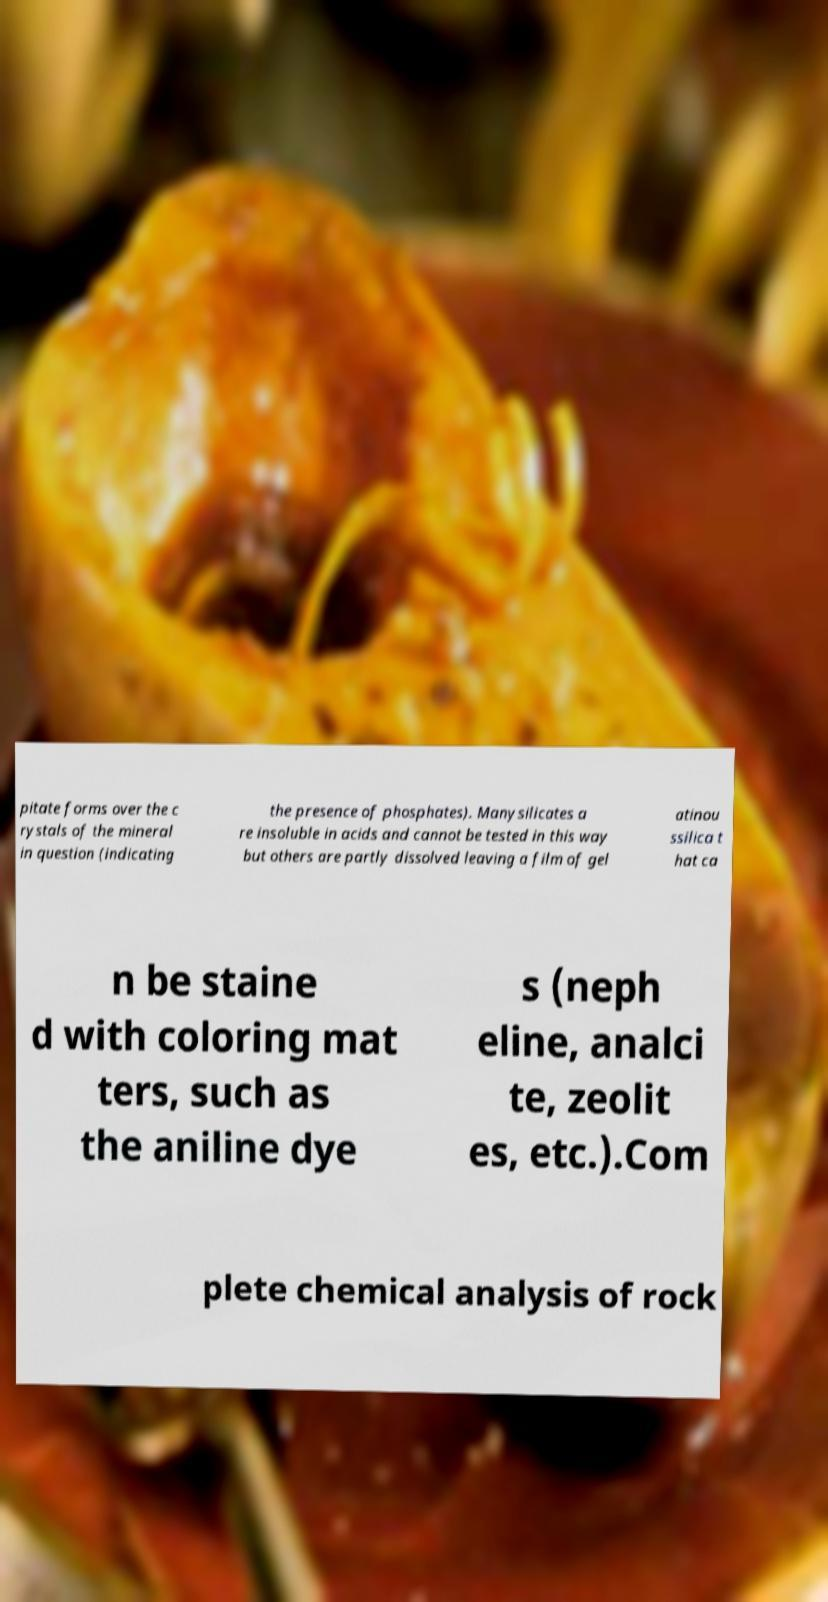For documentation purposes, I need the text within this image transcribed. Could you provide that? pitate forms over the c rystals of the mineral in question (indicating the presence of phosphates). Manysilicates a re insoluble in acids and cannot be tested in this way but others are partly dissolved leaving a film of gel atinou ssilica t hat ca n be staine d with coloring mat ters, such as the aniline dye s (neph eline, analci te, zeolit es, etc.).Com plete chemical analysis of rock 